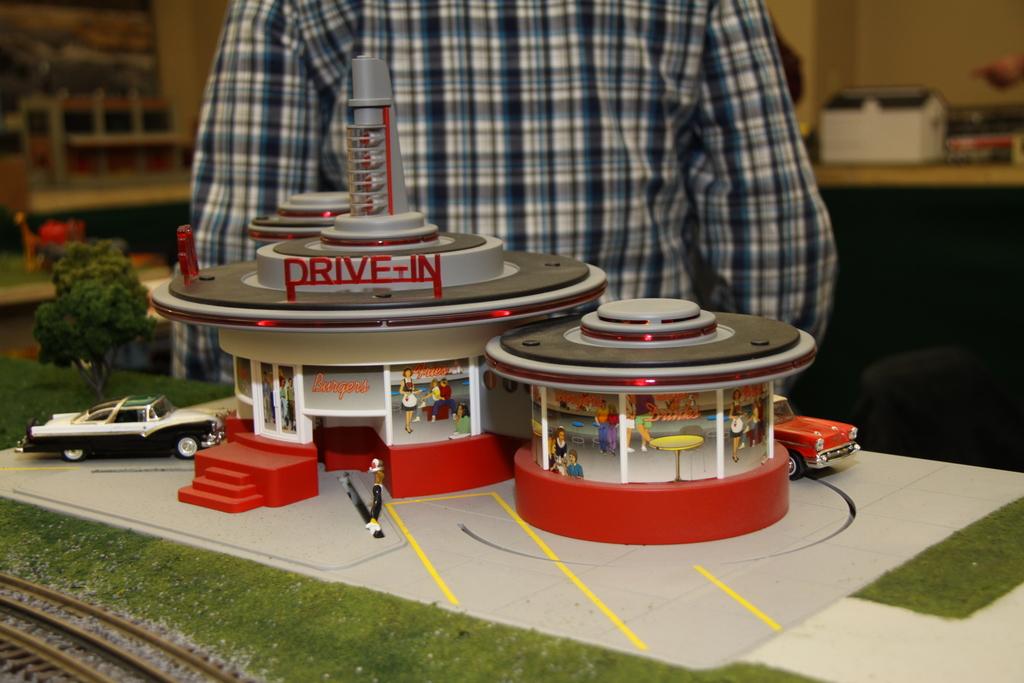What is the model a scale replica of?
Make the answer very short. Drive-in. 